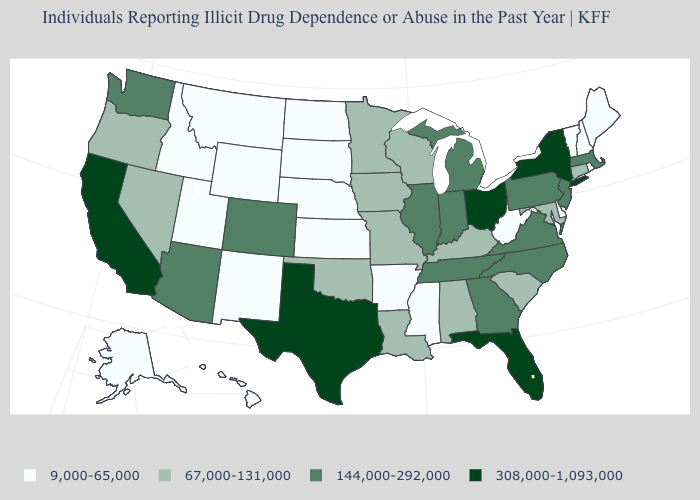Does Colorado have a lower value than California?
Give a very brief answer. Yes. Name the states that have a value in the range 308,000-1,093,000?
Answer briefly. California, Florida, New York, Ohio, Texas. Name the states that have a value in the range 67,000-131,000?
Give a very brief answer. Alabama, Connecticut, Iowa, Kentucky, Louisiana, Maryland, Minnesota, Missouri, Nevada, Oklahoma, Oregon, South Carolina, Wisconsin. Among the states that border New York , which have the lowest value?
Keep it brief. Vermont. Which states hav the highest value in the MidWest?
Write a very short answer. Ohio. What is the highest value in the USA?
Be succinct. 308,000-1,093,000. Name the states that have a value in the range 308,000-1,093,000?
Keep it brief. California, Florida, New York, Ohio, Texas. Name the states that have a value in the range 9,000-65,000?
Keep it brief. Alaska, Arkansas, Delaware, Hawaii, Idaho, Kansas, Maine, Mississippi, Montana, Nebraska, New Hampshire, New Mexico, North Dakota, Rhode Island, South Dakota, Utah, Vermont, West Virginia, Wyoming. What is the value of Hawaii?
Give a very brief answer. 9,000-65,000. What is the value of New York?
Short answer required. 308,000-1,093,000. Does Vermont have the highest value in the Northeast?
Concise answer only. No. Does Montana have the lowest value in the USA?
Quick response, please. Yes. What is the value of Arizona?
Keep it brief. 144,000-292,000. What is the highest value in states that border Mississippi?
Keep it brief. 144,000-292,000. 